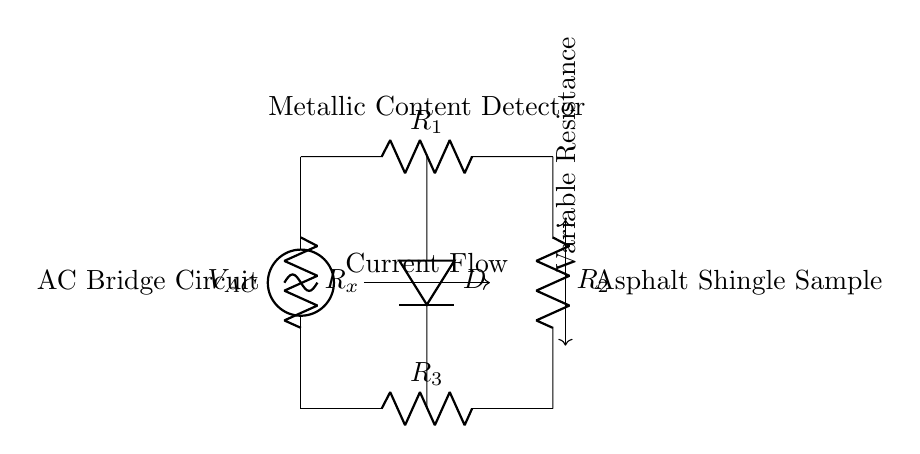What is the type of circuit shown? The circuit is categorized as a bridge circuit because it consists of four resistors arranged in a diamond shape with a detector measuring the imbalance across the diagonal.
Answer: bridge What does the variable resistance control? The variable resistance adjusts the resistance in the circuit, which helps in balancing the bridge and thereby indicates the metallic content in the asphalt shingles when the bridge is out of balance.
Answer: balancing How many resistors are in the circuit? There are four resistors present in the circuit, denoted as R1, R2, R3, and Rx.
Answer: four What is the function of the detector in this circuit? The detector measures the current flow resulting from the imbalance created by the metallic content in the asphalt shingle sample, indicating its metallic properties.
Answer: measurement What would happen to the bridge if the resistance Rx increases? If the resistance Rx increases, it will cause a greater imbalance in the bridge circuit, leading to a higher current through the detector, which indicates a higher metallic content in the sample.
Answer: higher current Where is the AC voltage source connected in relation to the resistors? The AC voltage source is connected to the top and bottom of the bridge circuit, with the resistors arranged between its two terminals, creating the potential difference across the resistors.
Answer: top and bottom 